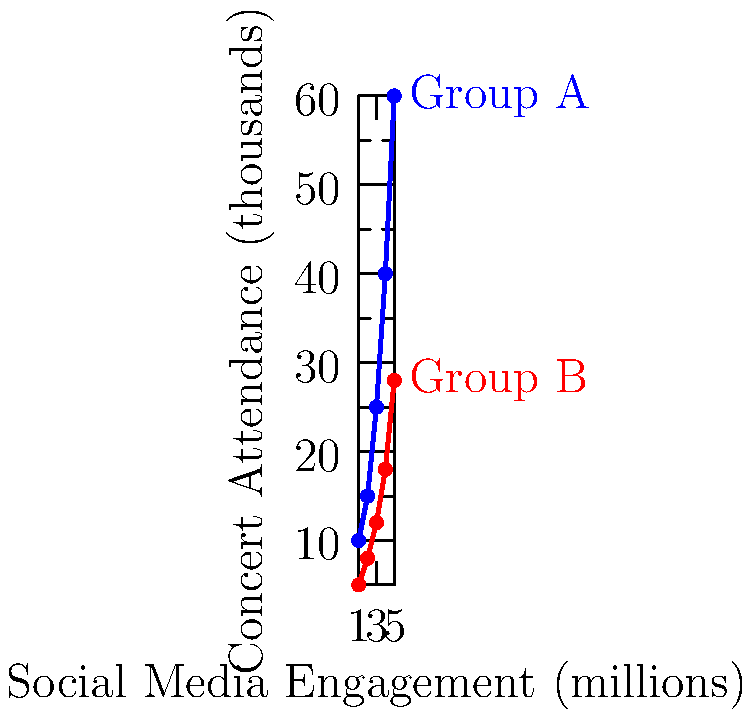Based on the graph showing the relationship between social media engagement and concert attendance for two K-pop groups, what would be the expected concert attendance (in thousands) for Group A if their social media engagement reaches 6 million? To predict the concert attendance for Group A at 6 million social media engagements, we need to follow these steps:

1. Observe that the relationship appears to be non-linear, with an increasing rate of growth.

2. Calculate the rate of change between the last two data points for Group A:
   - Social media engagement change: $5 - 4 = 1$ million
   - Concert attendance change: $60 - 40 = 20$ thousand

3. The rate of change is increasing, so we can expect the next increment to be larger.

4. Estimate the next increment:
   - Previous increment: 20 thousand
   - Estimated new increment: $20 * 1.2 = 24$ thousand (assuming 20% increase in growth rate)

5. Add this increment to the last known attendance:
   $60 + 24 = 84$ thousand

6. Round to the nearest thousand for a reasonable estimate.

This method takes into account the non-linear growth and provides a conservative estimate based on the trend.
Answer: 84,000 